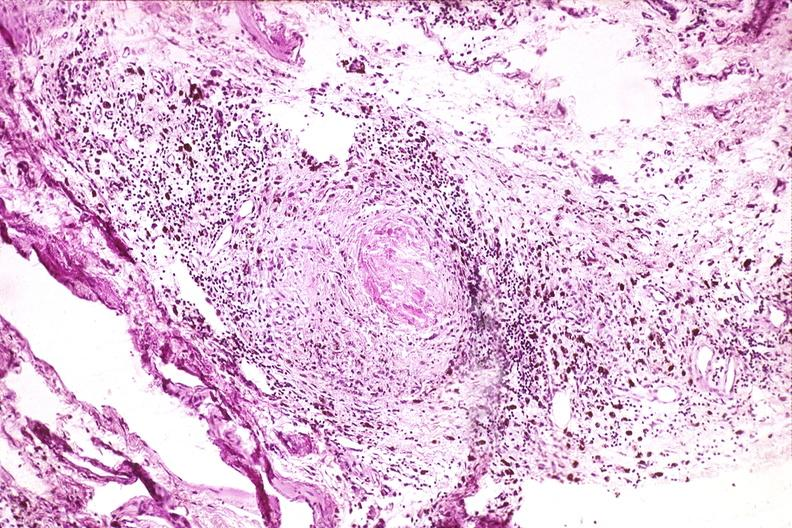does this image show synovium, pannus and fibrinoid necrosis, rheumatoid arthritis?
Answer the question using a single word or phrase. Yes 